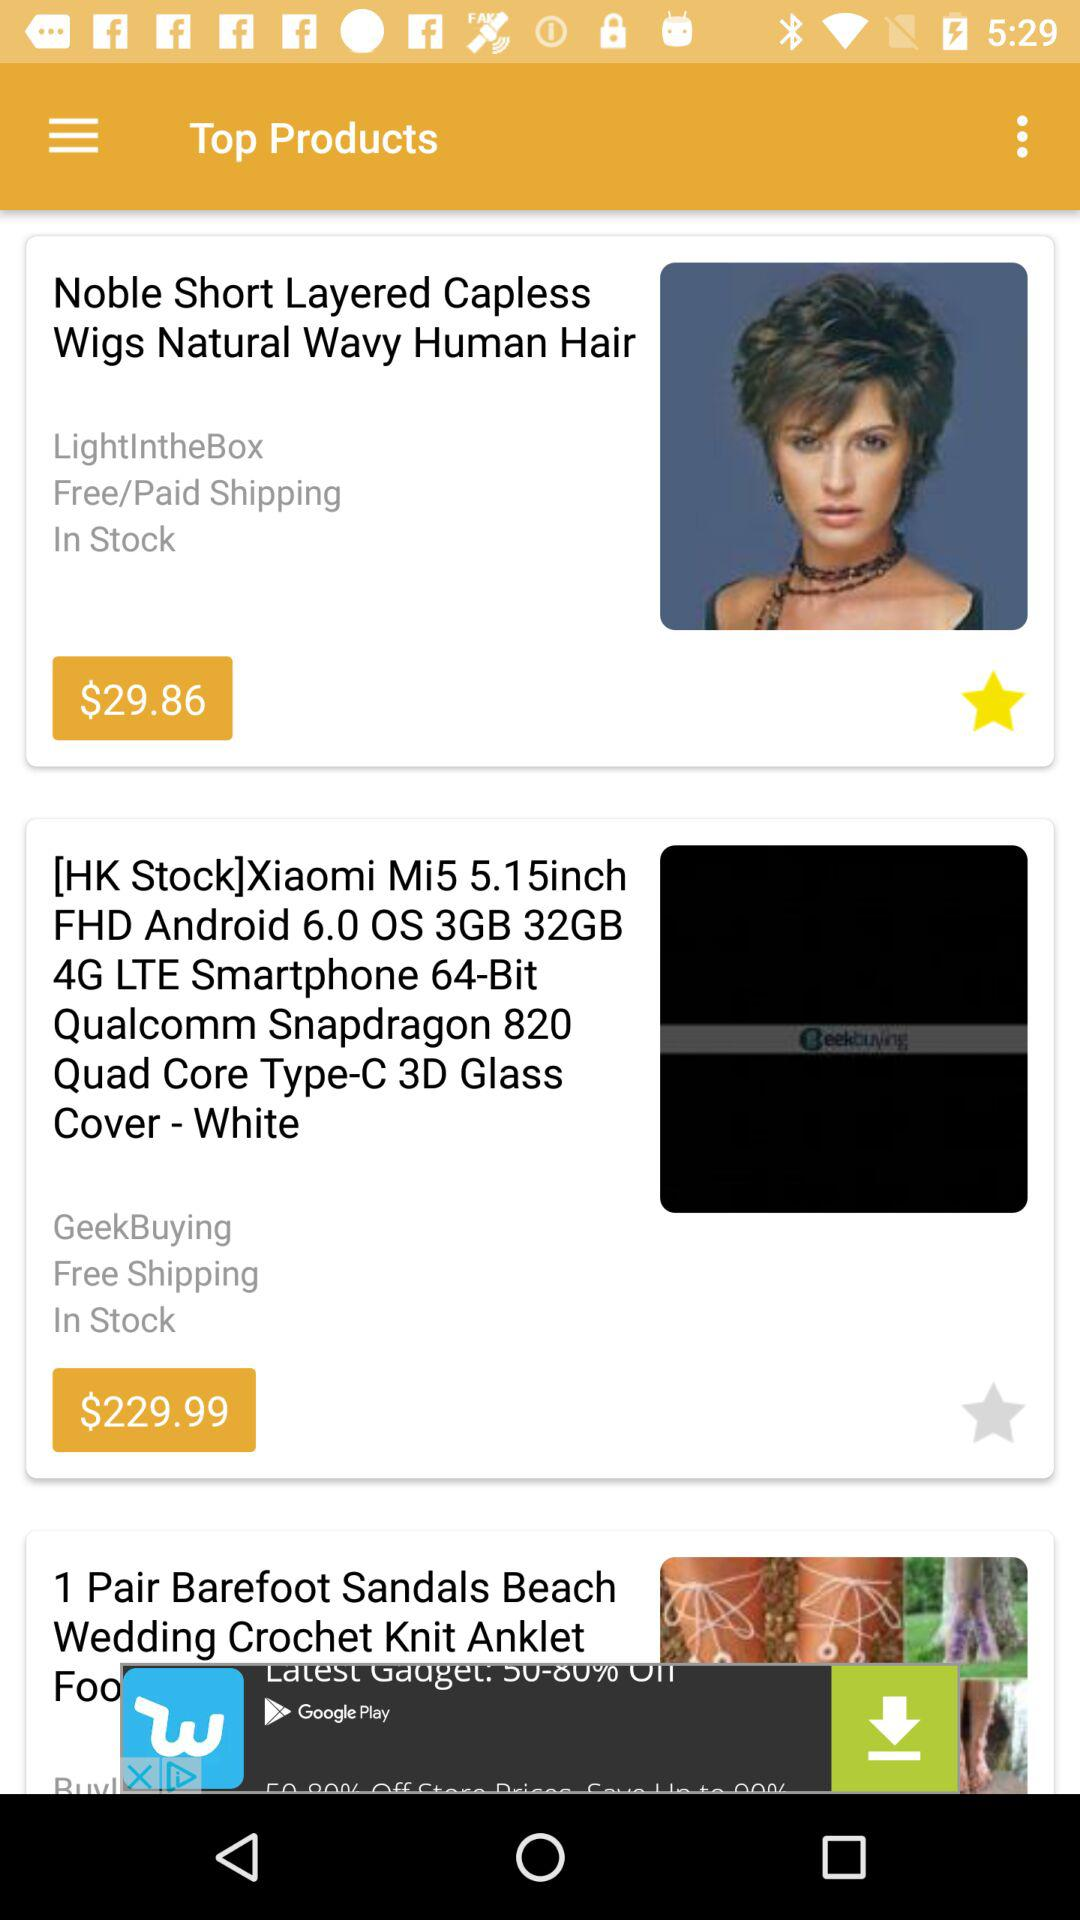Which product has free shipping? The products are "Noble Short Layered Capless Wigs Natural Wavy Human Hair" and "Xiaomi Mi5 5.15inch FHD Android 6.0 OS 3GB 32GB 4G LTE Smartphone 64-Bit Qualcomm Snapdragon 820 Quad Core Type-C 3D Glass Cover - White". 